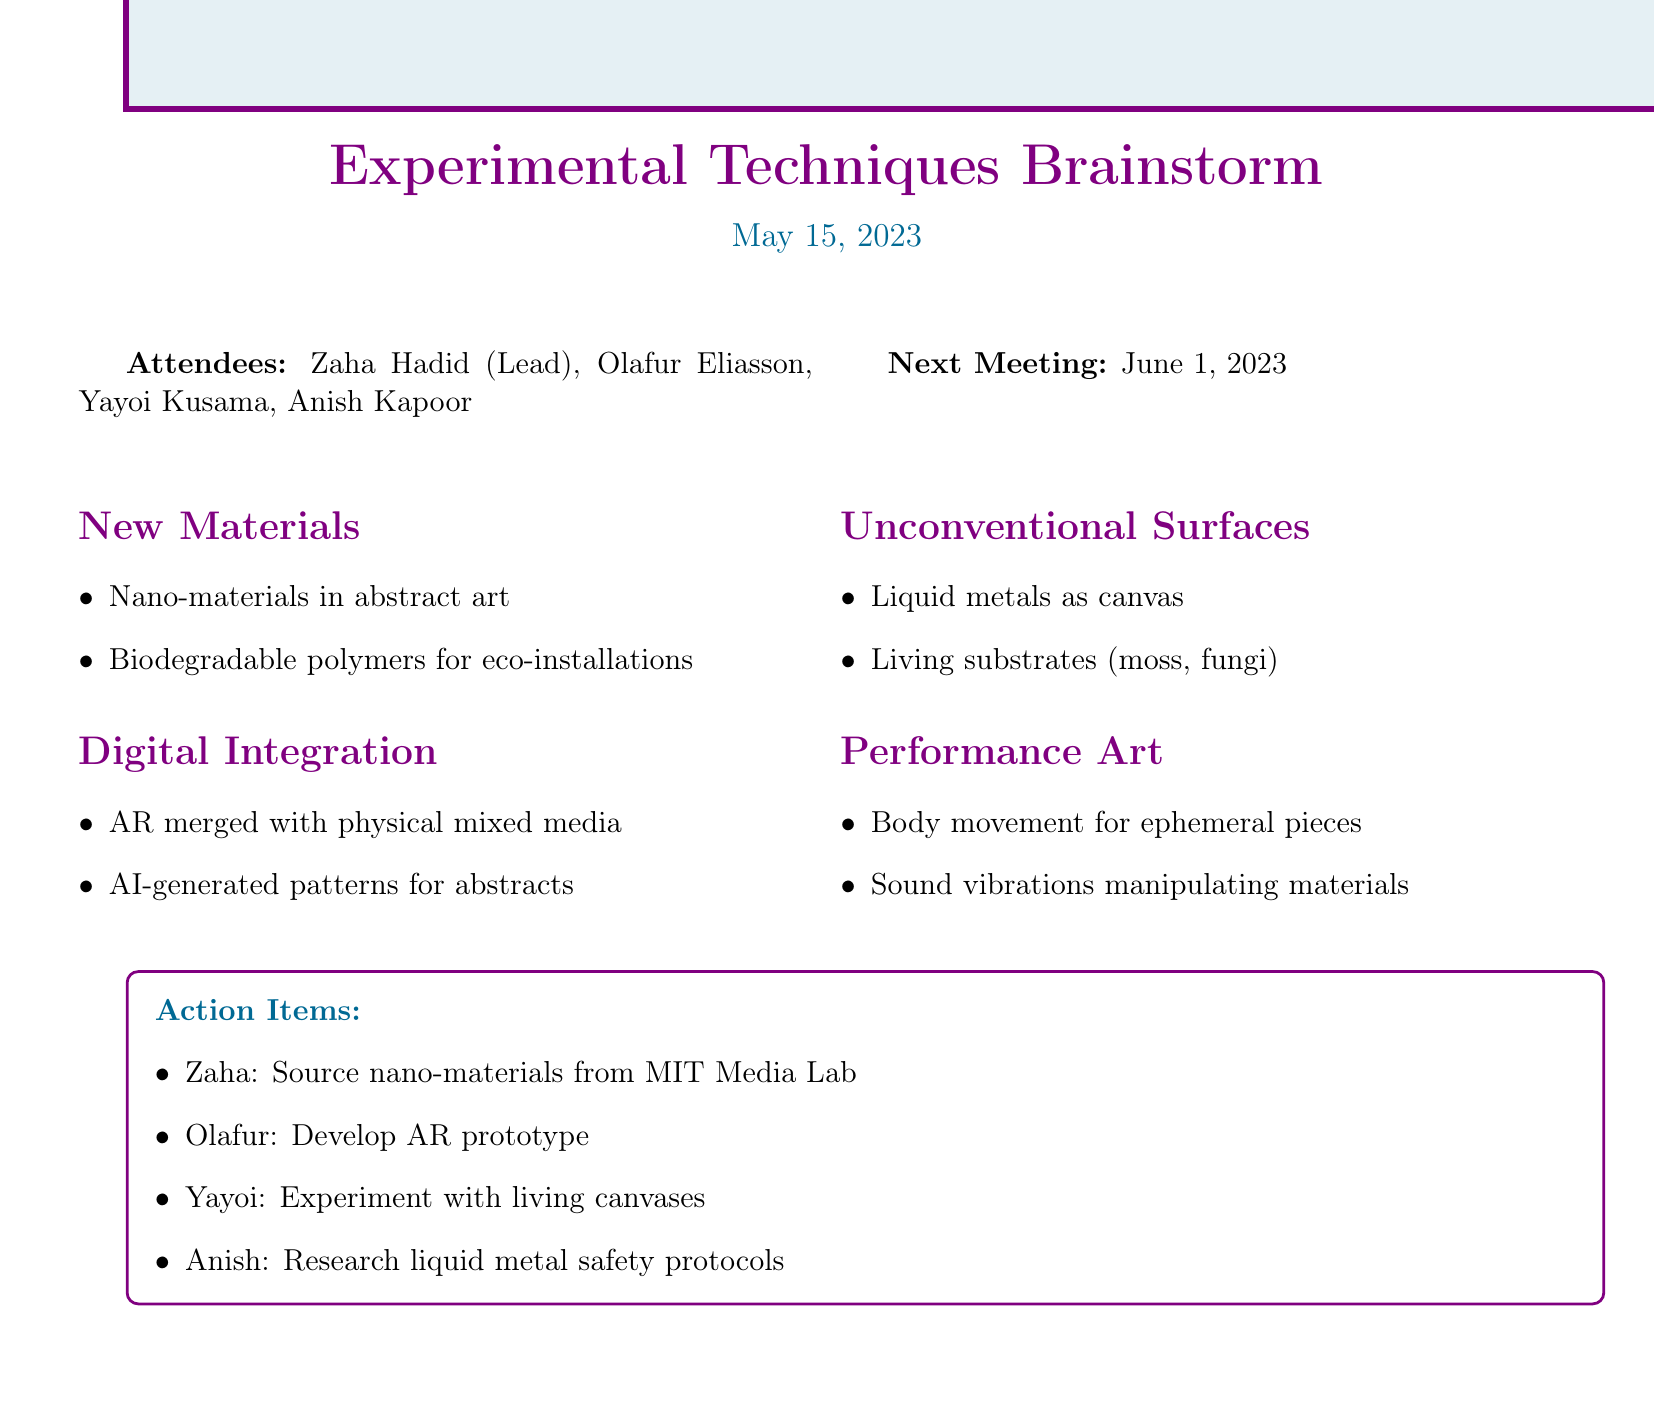what is the meeting title? The meeting title is directly stated in the document as the main topic of discussion.
Answer: Brainstorming Session: New Experimental Techniques in Mixed Media Artwork who is the lead artist? The lead artist is listed among the attendees, who are part of the meeting.
Answer: Zaha Hadid what date is the meeting scheduled for? The date of the meeting is clearly specified in the document.
Answer: 2023-05-15 how many attendees were present at the meeting? The number of attendees is a factual piece of information that can be counted from the list provided.
Answer: 4 which material is Zaha responsible for sourcing? The action items section specifies the responsibility assigned to Zaha.
Answer: nano-materials what is one of the unconventional surfaces discussed? The document lists specific topics under unconventional surfaces that were discussed in the meeting.
Answer: liquid metals who should develop the AR prototype? The responsibility for developing the AR prototype is assigned to one of the attendees in the action items.
Answer: Olafur what is the focus of the next meeting? The next meeting is designated a specific date noted at the end of the document.
Answer: 2023-06-01 how many action items are listed? The number of action items can be counted from the list provided in the document.
Answer: 4 